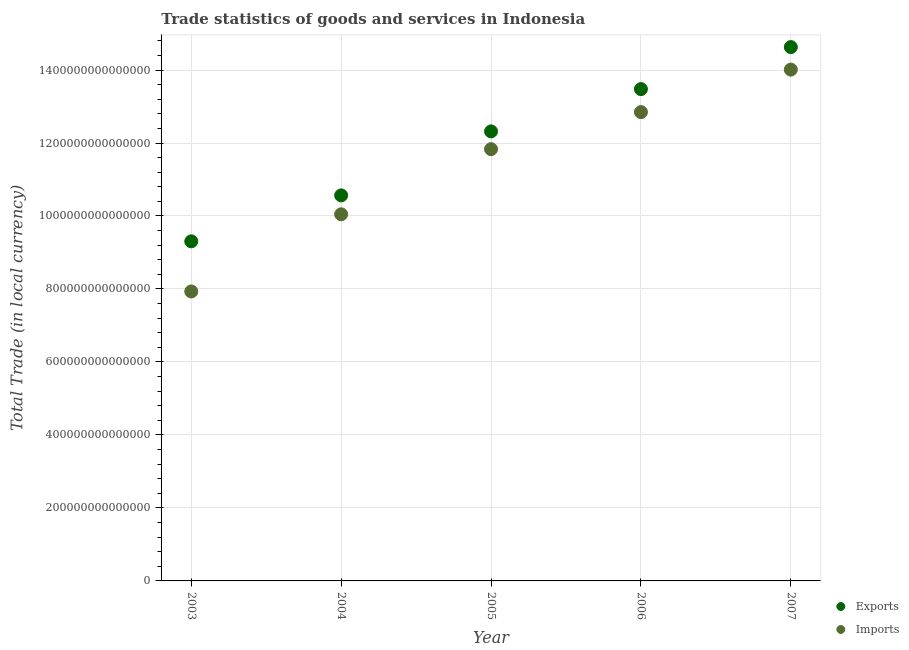How many different coloured dotlines are there?
Give a very brief answer. 2. Is the number of dotlines equal to the number of legend labels?
Offer a very short reply. Yes. What is the export of goods and services in 2005?
Ensure brevity in your answer.  1.23e+15. Across all years, what is the maximum export of goods and services?
Keep it short and to the point. 1.46e+15. Across all years, what is the minimum imports of goods and services?
Your answer should be very brief. 7.93e+14. In which year was the imports of goods and services maximum?
Your answer should be very brief. 2007. What is the total imports of goods and services in the graph?
Offer a terse response. 5.67e+15. What is the difference between the imports of goods and services in 2005 and that in 2006?
Provide a short and direct response. -1.02e+14. What is the difference between the export of goods and services in 2007 and the imports of goods and services in 2004?
Make the answer very short. 4.58e+14. What is the average imports of goods and services per year?
Your answer should be very brief. 1.13e+15. In the year 2004, what is the difference between the export of goods and services and imports of goods and services?
Offer a terse response. 5.18e+13. What is the ratio of the export of goods and services in 2005 to that in 2006?
Keep it short and to the point. 0.91. Is the difference between the export of goods and services in 2006 and 2007 greater than the difference between the imports of goods and services in 2006 and 2007?
Your answer should be compact. Yes. What is the difference between the highest and the second highest imports of goods and services?
Your response must be concise. 1.16e+14. What is the difference between the highest and the lowest imports of goods and services?
Offer a terse response. 6.08e+14. In how many years, is the imports of goods and services greater than the average imports of goods and services taken over all years?
Your answer should be compact. 3. How many dotlines are there?
Make the answer very short. 2. What is the difference between two consecutive major ticks on the Y-axis?
Provide a short and direct response. 2.00e+14. Are the values on the major ticks of Y-axis written in scientific E-notation?
Provide a succinct answer. No. Does the graph contain any zero values?
Provide a short and direct response. No. Does the graph contain grids?
Your answer should be very brief. Yes. How many legend labels are there?
Offer a very short reply. 2. How are the legend labels stacked?
Your response must be concise. Vertical. What is the title of the graph?
Your response must be concise. Trade statistics of goods and services in Indonesia. What is the label or title of the X-axis?
Offer a terse response. Year. What is the label or title of the Y-axis?
Provide a succinct answer. Total Trade (in local currency). What is the Total Trade (in local currency) in Exports in 2003?
Make the answer very short. 9.31e+14. What is the Total Trade (in local currency) of Imports in 2003?
Offer a terse response. 7.93e+14. What is the Total Trade (in local currency) in Exports in 2004?
Provide a short and direct response. 1.06e+15. What is the Total Trade (in local currency) in Imports in 2004?
Your response must be concise. 1.00e+15. What is the Total Trade (in local currency) in Exports in 2005?
Make the answer very short. 1.23e+15. What is the Total Trade (in local currency) in Imports in 2005?
Offer a very short reply. 1.18e+15. What is the Total Trade (in local currency) in Exports in 2006?
Your answer should be compact. 1.35e+15. What is the Total Trade (in local currency) of Imports in 2006?
Make the answer very short. 1.28e+15. What is the Total Trade (in local currency) in Exports in 2007?
Your answer should be compact. 1.46e+15. What is the Total Trade (in local currency) of Imports in 2007?
Ensure brevity in your answer.  1.40e+15. Across all years, what is the maximum Total Trade (in local currency) in Exports?
Your response must be concise. 1.46e+15. Across all years, what is the maximum Total Trade (in local currency) in Imports?
Give a very brief answer. 1.40e+15. Across all years, what is the minimum Total Trade (in local currency) of Exports?
Ensure brevity in your answer.  9.31e+14. Across all years, what is the minimum Total Trade (in local currency) in Imports?
Make the answer very short. 7.93e+14. What is the total Total Trade (in local currency) in Exports in the graph?
Offer a very short reply. 6.03e+15. What is the total Total Trade (in local currency) of Imports in the graph?
Make the answer very short. 5.67e+15. What is the difference between the Total Trade (in local currency) of Exports in 2003 and that in 2004?
Your answer should be very brief. -1.26e+14. What is the difference between the Total Trade (in local currency) in Imports in 2003 and that in 2004?
Your answer should be very brief. -2.11e+14. What is the difference between the Total Trade (in local currency) in Exports in 2003 and that in 2005?
Keep it short and to the point. -3.01e+14. What is the difference between the Total Trade (in local currency) of Imports in 2003 and that in 2005?
Provide a succinct answer. -3.90e+14. What is the difference between the Total Trade (in local currency) of Exports in 2003 and that in 2006?
Offer a very short reply. -4.17e+14. What is the difference between the Total Trade (in local currency) in Imports in 2003 and that in 2006?
Keep it short and to the point. -4.91e+14. What is the difference between the Total Trade (in local currency) in Exports in 2003 and that in 2007?
Make the answer very short. -5.32e+14. What is the difference between the Total Trade (in local currency) of Imports in 2003 and that in 2007?
Your answer should be very brief. -6.08e+14. What is the difference between the Total Trade (in local currency) of Exports in 2004 and that in 2005?
Your response must be concise. -1.75e+14. What is the difference between the Total Trade (in local currency) in Imports in 2004 and that in 2005?
Give a very brief answer. -1.79e+14. What is the difference between the Total Trade (in local currency) of Exports in 2004 and that in 2006?
Ensure brevity in your answer.  -2.91e+14. What is the difference between the Total Trade (in local currency) in Imports in 2004 and that in 2006?
Offer a terse response. -2.80e+14. What is the difference between the Total Trade (in local currency) of Exports in 2004 and that in 2007?
Your answer should be compact. -4.06e+14. What is the difference between the Total Trade (in local currency) in Imports in 2004 and that in 2007?
Make the answer very short. -3.97e+14. What is the difference between the Total Trade (in local currency) of Exports in 2005 and that in 2006?
Make the answer very short. -1.16e+14. What is the difference between the Total Trade (in local currency) of Imports in 2005 and that in 2006?
Your response must be concise. -1.02e+14. What is the difference between the Total Trade (in local currency) in Exports in 2005 and that in 2007?
Provide a succinct answer. -2.31e+14. What is the difference between the Total Trade (in local currency) in Imports in 2005 and that in 2007?
Provide a succinct answer. -2.18e+14. What is the difference between the Total Trade (in local currency) in Exports in 2006 and that in 2007?
Provide a short and direct response. -1.15e+14. What is the difference between the Total Trade (in local currency) in Imports in 2006 and that in 2007?
Give a very brief answer. -1.16e+14. What is the difference between the Total Trade (in local currency) in Exports in 2003 and the Total Trade (in local currency) in Imports in 2004?
Keep it short and to the point. -7.41e+13. What is the difference between the Total Trade (in local currency) of Exports in 2003 and the Total Trade (in local currency) of Imports in 2005?
Your answer should be compact. -2.53e+14. What is the difference between the Total Trade (in local currency) in Exports in 2003 and the Total Trade (in local currency) in Imports in 2006?
Make the answer very short. -3.54e+14. What is the difference between the Total Trade (in local currency) in Exports in 2003 and the Total Trade (in local currency) in Imports in 2007?
Make the answer very short. -4.71e+14. What is the difference between the Total Trade (in local currency) of Exports in 2004 and the Total Trade (in local currency) of Imports in 2005?
Offer a terse response. -1.27e+14. What is the difference between the Total Trade (in local currency) in Exports in 2004 and the Total Trade (in local currency) in Imports in 2006?
Ensure brevity in your answer.  -2.28e+14. What is the difference between the Total Trade (in local currency) of Exports in 2004 and the Total Trade (in local currency) of Imports in 2007?
Offer a terse response. -3.45e+14. What is the difference between the Total Trade (in local currency) in Exports in 2005 and the Total Trade (in local currency) in Imports in 2006?
Provide a short and direct response. -5.29e+13. What is the difference between the Total Trade (in local currency) in Exports in 2005 and the Total Trade (in local currency) in Imports in 2007?
Keep it short and to the point. -1.69e+14. What is the difference between the Total Trade (in local currency) of Exports in 2006 and the Total Trade (in local currency) of Imports in 2007?
Offer a very short reply. -5.34e+13. What is the average Total Trade (in local currency) of Exports per year?
Give a very brief answer. 1.21e+15. What is the average Total Trade (in local currency) in Imports per year?
Keep it short and to the point. 1.13e+15. In the year 2003, what is the difference between the Total Trade (in local currency) in Exports and Total Trade (in local currency) in Imports?
Your answer should be compact. 1.37e+14. In the year 2004, what is the difference between the Total Trade (in local currency) in Exports and Total Trade (in local currency) in Imports?
Offer a terse response. 5.18e+13. In the year 2005, what is the difference between the Total Trade (in local currency) of Exports and Total Trade (in local currency) of Imports?
Your response must be concise. 4.87e+13. In the year 2006, what is the difference between the Total Trade (in local currency) of Exports and Total Trade (in local currency) of Imports?
Offer a very short reply. 6.30e+13. In the year 2007, what is the difference between the Total Trade (in local currency) in Exports and Total Trade (in local currency) in Imports?
Ensure brevity in your answer.  6.17e+13. What is the ratio of the Total Trade (in local currency) in Exports in 2003 to that in 2004?
Provide a short and direct response. 0.88. What is the ratio of the Total Trade (in local currency) of Imports in 2003 to that in 2004?
Provide a succinct answer. 0.79. What is the ratio of the Total Trade (in local currency) in Exports in 2003 to that in 2005?
Make the answer very short. 0.76. What is the ratio of the Total Trade (in local currency) in Imports in 2003 to that in 2005?
Make the answer very short. 0.67. What is the ratio of the Total Trade (in local currency) in Exports in 2003 to that in 2006?
Provide a succinct answer. 0.69. What is the ratio of the Total Trade (in local currency) of Imports in 2003 to that in 2006?
Offer a terse response. 0.62. What is the ratio of the Total Trade (in local currency) of Exports in 2003 to that in 2007?
Make the answer very short. 0.64. What is the ratio of the Total Trade (in local currency) in Imports in 2003 to that in 2007?
Give a very brief answer. 0.57. What is the ratio of the Total Trade (in local currency) in Exports in 2004 to that in 2005?
Offer a very short reply. 0.86. What is the ratio of the Total Trade (in local currency) in Imports in 2004 to that in 2005?
Your answer should be compact. 0.85. What is the ratio of the Total Trade (in local currency) in Exports in 2004 to that in 2006?
Your answer should be very brief. 0.78. What is the ratio of the Total Trade (in local currency) in Imports in 2004 to that in 2006?
Ensure brevity in your answer.  0.78. What is the ratio of the Total Trade (in local currency) of Exports in 2004 to that in 2007?
Give a very brief answer. 0.72. What is the ratio of the Total Trade (in local currency) in Imports in 2004 to that in 2007?
Ensure brevity in your answer.  0.72. What is the ratio of the Total Trade (in local currency) in Exports in 2005 to that in 2006?
Provide a succinct answer. 0.91. What is the ratio of the Total Trade (in local currency) of Imports in 2005 to that in 2006?
Give a very brief answer. 0.92. What is the ratio of the Total Trade (in local currency) in Exports in 2005 to that in 2007?
Give a very brief answer. 0.84. What is the ratio of the Total Trade (in local currency) in Imports in 2005 to that in 2007?
Your response must be concise. 0.84. What is the ratio of the Total Trade (in local currency) of Exports in 2006 to that in 2007?
Your answer should be compact. 0.92. What is the ratio of the Total Trade (in local currency) in Imports in 2006 to that in 2007?
Your response must be concise. 0.92. What is the difference between the highest and the second highest Total Trade (in local currency) in Exports?
Offer a very short reply. 1.15e+14. What is the difference between the highest and the second highest Total Trade (in local currency) of Imports?
Keep it short and to the point. 1.16e+14. What is the difference between the highest and the lowest Total Trade (in local currency) in Exports?
Offer a terse response. 5.32e+14. What is the difference between the highest and the lowest Total Trade (in local currency) of Imports?
Provide a short and direct response. 6.08e+14. 